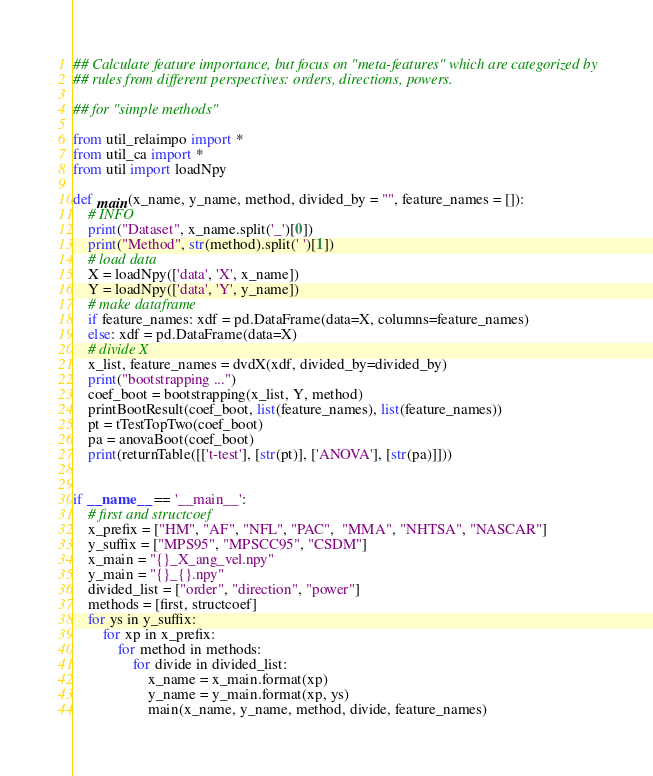<code> <loc_0><loc_0><loc_500><loc_500><_Python_>## Calculate feature importance, but focus on "meta-features" which are categorized by
## rules from different perspectives: orders, directions, powers.

## for "simple methods"

from util_relaimpo import *
from util_ca import *
from util import loadNpy

def main(x_name, y_name, method, divided_by = "", feature_names = []):
    # INFO
    print("Dataset", x_name.split('_')[0])
    print("Method", str(method).split(' ')[1])
    # load data
    X = loadNpy(['data', 'X', x_name])
    Y = loadNpy(['data', 'Y', y_name])
    # make dataframe
    if feature_names: xdf = pd.DataFrame(data=X, columns=feature_names)
    else: xdf = pd.DataFrame(data=X)
    # divide X
    x_list, feature_names = dvdX(xdf, divided_by=divided_by)
    print("bootstrapping ...")
    coef_boot = bootstrapping(x_list, Y, method)
    printBootResult(coef_boot, list(feature_names), list(feature_names))
    pt = tTestTopTwo(coef_boot)
    pa = anovaBoot(coef_boot)
    print(returnTable([['t-test'], [str(pt)], ['ANOVA'], [str(pa)]]))


if __name__ == '__main__':
    # first and structcoef
    x_prefix = ["HM", "AF", "NFL", "PAC",  "MMA", "NHTSA", "NASCAR"]
    y_suffix = ["MPS95", "MPSCC95", "CSDM"]
    x_main = "{}_X_ang_vel.npy"
    y_main = "{}_{}.npy"
    divided_list = ["order", "direction", "power"]
    methods = [first, structcoef]
    for ys in y_suffix:
        for xp in x_prefix:
            for method in methods:
                for divide in divided_list:
                    x_name = x_main.format(xp)
                    y_name = y_main.format(xp, ys)
                    main(x_name, y_name, method, divide, feature_names)
</code> 